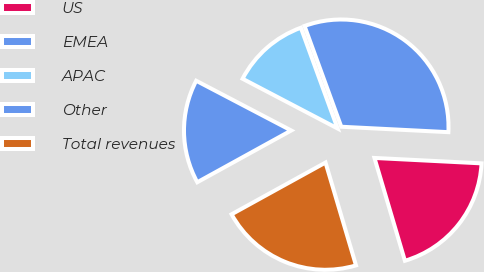<chart> <loc_0><loc_0><loc_500><loc_500><pie_chart><fcel>US<fcel>EMEA<fcel>APAC<fcel>Other<fcel>Total revenues<nl><fcel>19.61%<fcel>31.37%<fcel>11.76%<fcel>15.69%<fcel>21.57%<nl></chart> 